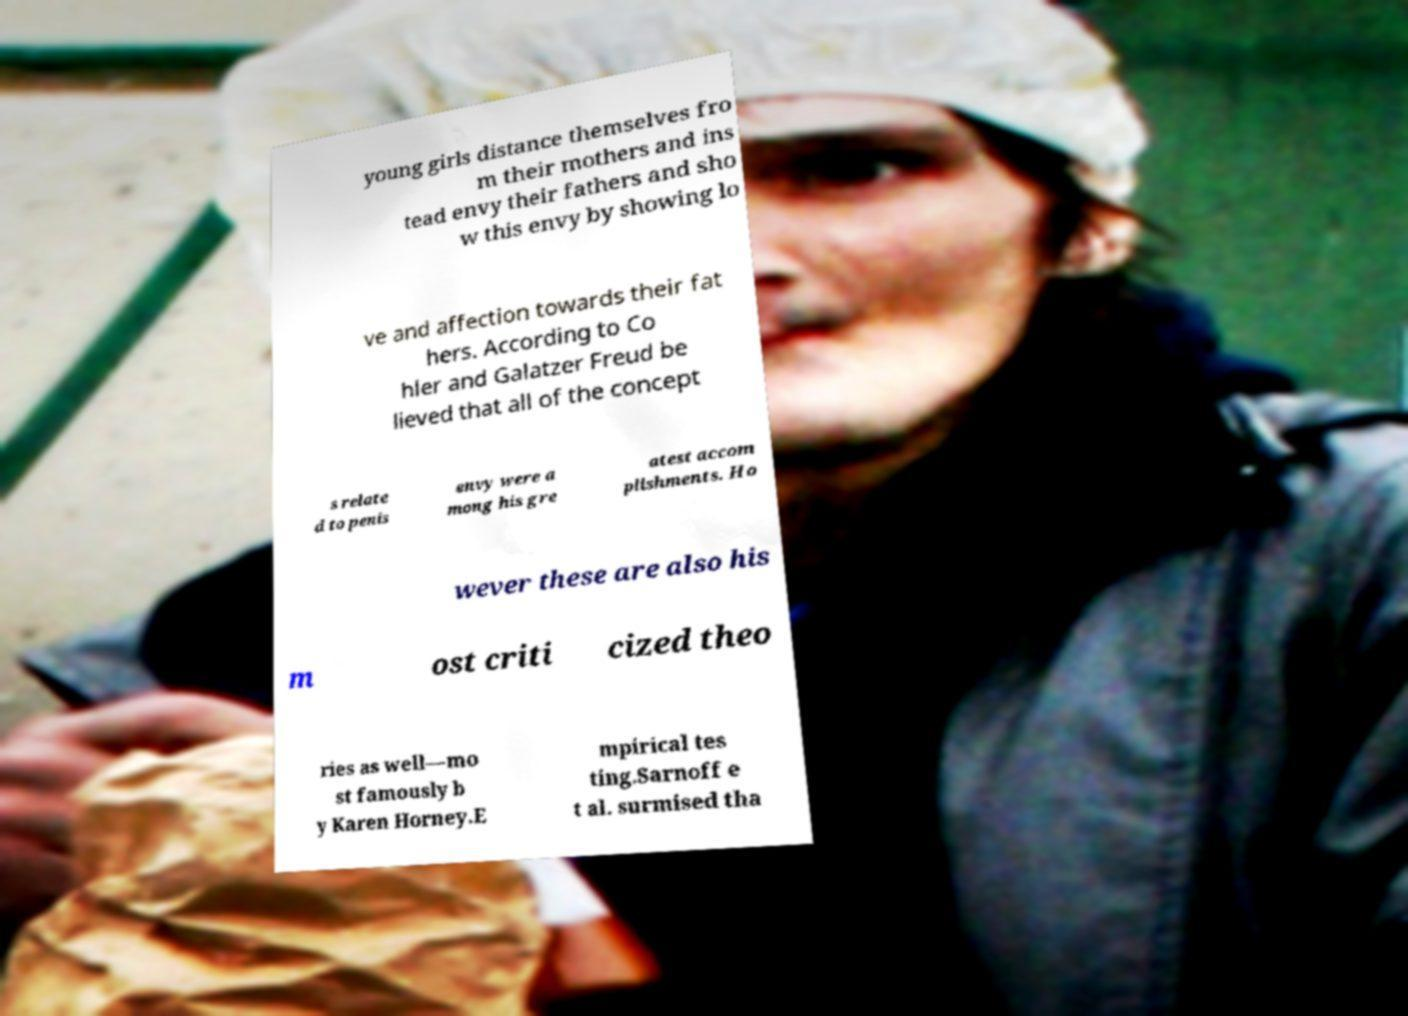Could you extract and type out the text from this image? young girls distance themselves fro m their mothers and ins tead envy their fathers and sho w this envy by showing lo ve and affection towards their fat hers. According to Co hler and Galatzer Freud be lieved that all of the concept s relate d to penis envy were a mong his gre atest accom plishments. Ho wever these are also his m ost criti cized theo ries as well—mo st famously b y Karen Horney.E mpirical tes ting.Sarnoff e t al. surmised tha 